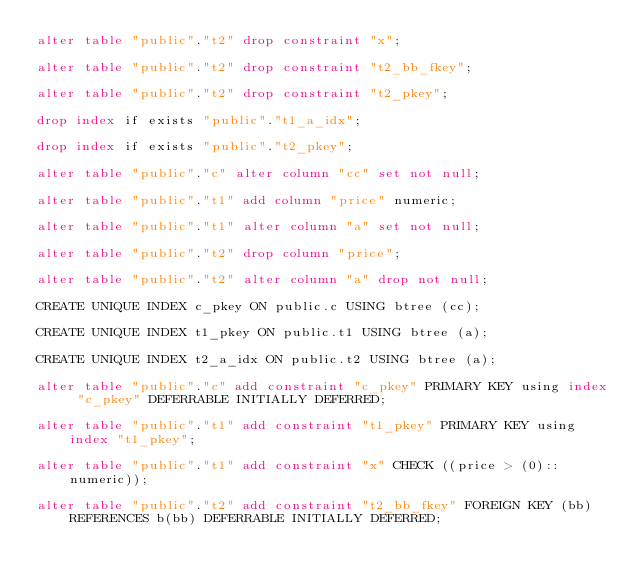<code> <loc_0><loc_0><loc_500><loc_500><_SQL_>alter table "public"."t2" drop constraint "x";

alter table "public"."t2" drop constraint "t2_bb_fkey";

alter table "public"."t2" drop constraint "t2_pkey";

drop index if exists "public"."t1_a_idx";

drop index if exists "public"."t2_pkey";

alter table "public"."c" alter column "cc" set not null;

alter table "public"."t1" add column "price" numeric;

alter table "public"."t1" alter column "a" set not null;

alter table "public"."t2" drop column "price";

alter table "public"."t2" alter column "a" drop not null;

CREATE UNIQUE INDEX c_pkey ON public.c USING btree (cc);

CREATE UNIQUE INDEX t1_pkey ON public.t1 USING btree (a);

CREATE UNIQUE INDEX t2_a_idx ON public.t2 USING btree (a);

alter table "public"."c" add constraint "c_pkey" PRIMARY KEY using index "c_pkey" DEFERRABLE INITIALLY DEFERRED;

alter table "public"."t1" add constraint "t1_pkey" PRIMARY KEY using index "t1_pkey";

alter table "public"."t1" add constraint "x" CHECK ((price > (0)::numeric));

alter table "public"."t2" add constraint "t2_bb_fkey" FOREIGN KEY (bb) REFERENCES b(bb) DEFERRABLE INITIALLY DEFERRED;</code> 